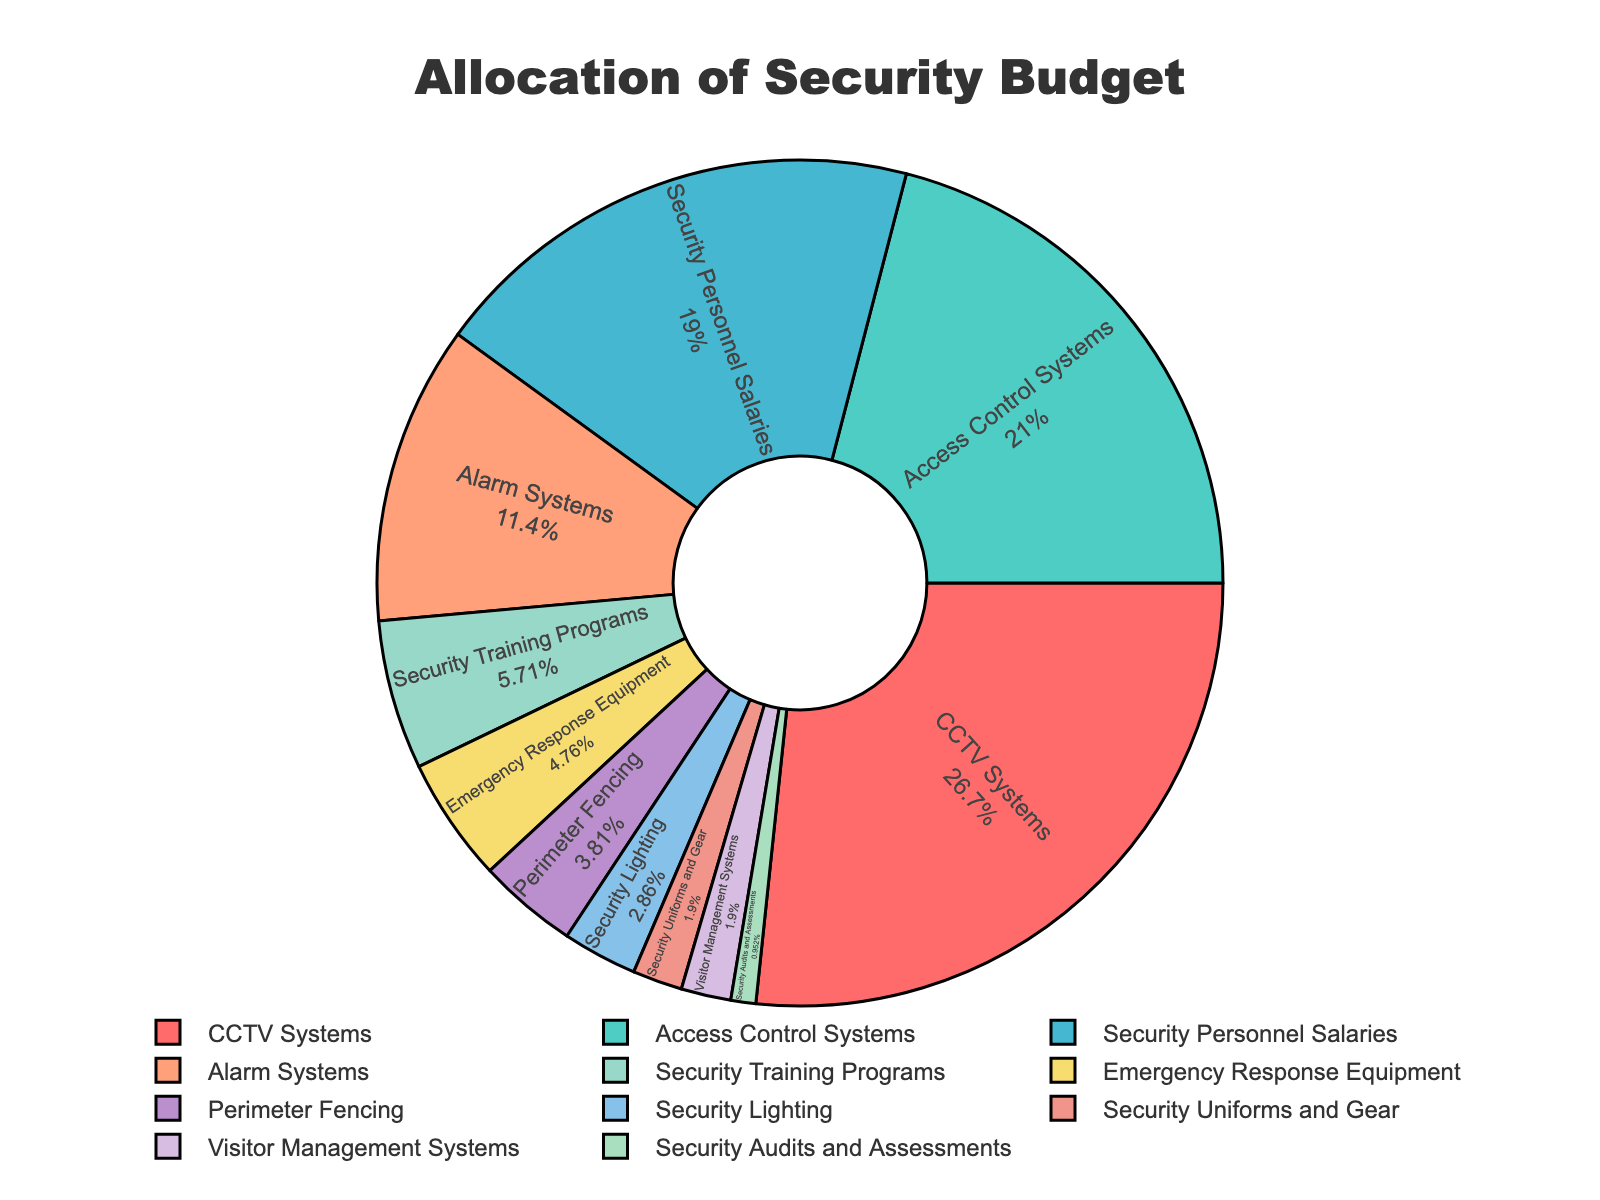What is the largest category in the security budget pie chart? By looking at the chart, the largest section has the highest percentage which is labeled accordingly. The "CCTV Systems" slice has the highest value at 28%.
Answer: CCTV Systems What is the combined percentage of Security Personnel Salaries and Security Training Programs? To get this, sum the percentages for "Security Personnel Salaries" and "Security Training Programs." These are 20% and 6%, respectively. 20 + 6 = 26
Answer: 26% Which category has a smaller allocation, Alarm Systems or Access Control Systems? Compare the percentages for "Alarm Systems" and "Access Control Systems." "Alarm Systems" is 12%, while "Access Control Systems" is 22%, making Alarm Systems smaller.
Answer: Alarm Systems What is the visual characteristic of the category with the smallest allocation? Identify the smallest slice in the chart visually. The "Security Audits and Assessments" slice is the smallest at 1%, and it is represented in the legend and pie chart by color and size measures.
Answer: Security Audits and Assessments How much more percentage is allocated to Emergency Response Equipment compared to Security Lighting? Subtract the percentage of "Security Lighting" from "Emergency Response Equipment." These are 5% and 3%, respectively. 5 - 3 = 2
Answer: 2% What is the difference in percentage allocation between the highest and lowest categories? Subtract the lowest percentage from the highest. The highest is "CCTV Systems" at 28% and the lowest is "Security Audits and Assessments" at 1%. 28 - 1 = 27
Answer: 27% What category is allocated 3% of the budget? Identify the slice labeled with 3% in the pie chart. "Security Lighting" has a 3% allocation.
Answer: Security Lighting Which two categories have equal percentage allocations, and what is that percentage? Identify categories whose percentage values are the same. Both "Visitor Management Systems" and "Security Uniforms and Gear" have a 2% allocation each.
Answer: Visitor Management Systems and Security Uniforms and Gear; 2% Is the percentage for Alarm Systems closer to Security Personnel Salaries or to Access Control Systems? Compare the percentage of "Alarm Systems" which is 12%, with "Security Personnel Salaries" at 20%, and "Access Control Systems" at 22%. 20 - 12 = 8, 22 - 12 = 10. It is closer to "Security Personnel Salaries."
Answer: Security Personnel Salaries 